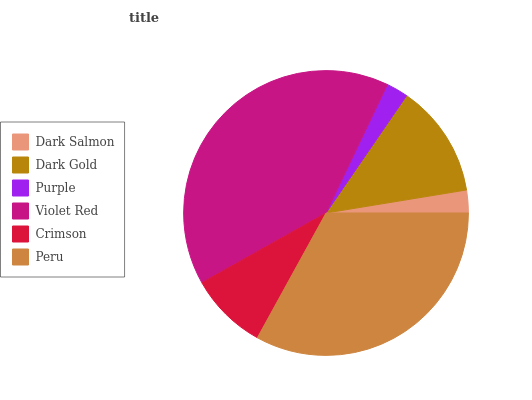Is Purple the minimum?
Answer yes or no. Yes. Is Violet Red the maximum?
Answer yes or no. Yes. Is Dark Gold the minimum?
Answer yes or no. No. Is Dark Gold the maximum?
Answer yes or no. No. Is Dark Gold greater than Dark Salmon?
Answer yes or no. Yes. Is Dark Salmon less than Dark Gold?
Answer yes or no. Yes. Is Dark Salmon greater than Dark Gold?
Answer yes or no. No. Is Dark Gold less than Dark Salmon?
Answer yes or no. No. Is Dark Gold the high median?
Answer yes or no. Yes. Is Crimson the low median?
Answer yes or no. Yes. Is Purple the high median?
Answer yes or no. No. Is Peru the low median?
Answer yes or no. No. 